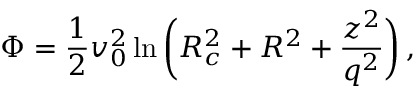Convert formula to latex. <formula><loc_0><loc_0><loc_500><loc_500>\Phi = \frac { 1 } { 2 } v _ { 0 } ^ { 2 } \ln \left ( R _ { c } ^ { 2 } + R ^ { 2 } + \frac { z ^ { 2 } } { q ^ { 2 } } \right ) \, ,</formula> 